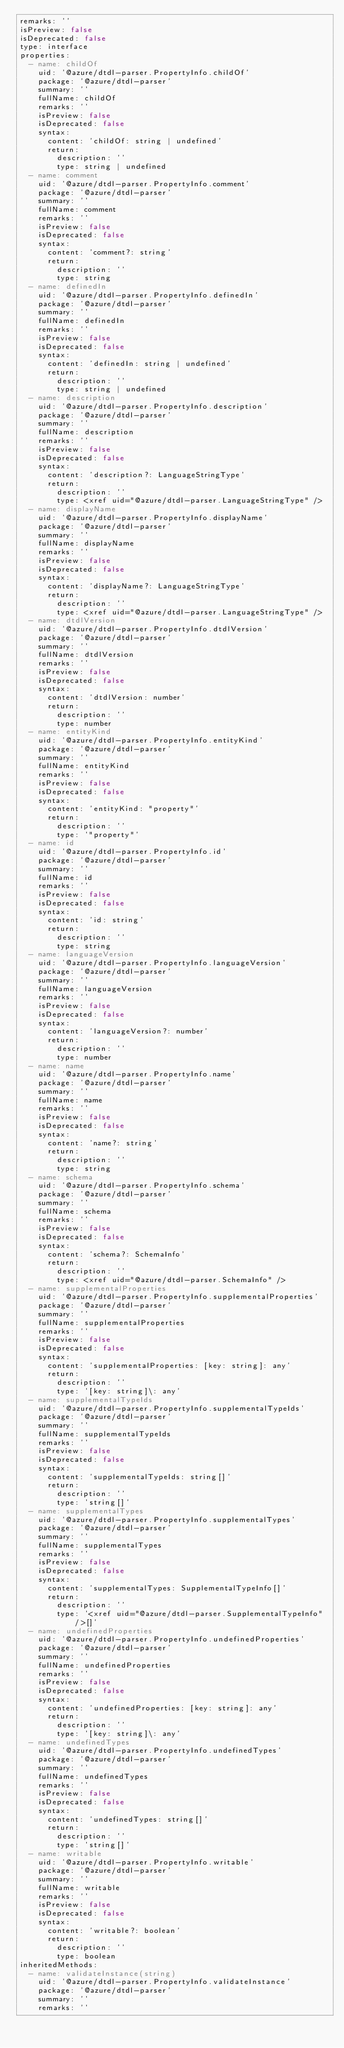Convert code to text. <code><loc_0><loc_0><loc_500><loc_500><_YAML_>remarks: ''
isPreview: false
isDeprecated: false
type: interface
properties:
  - name: childOf
    uid: '@azure/dtdl-parser.PropertyInfo.childOf'
    package: '@azure/dtdl-parser'
    summary: ''
    fullName: childOf
    remarks: ''
    isPreview: false
    isDeprecated: false
    syntax:
      content: 'childOf: string | undefined'
      return:
        description: ''
        type: string | undefined
  - name: comment
    uid: '@azure/dtdl-parser.PropertyInfo.comment'
    package: '@azure/dtdl-parser'
    summary: ''
    fullName: comment
    remarks: ''
    isPreview: false
    isDeprecated: false
    syntax:
      content: 'comment?: string'
      return:
        description: ''
        type: string
  - name: definedIn
    uid: '@azure/dtdl-parser.PropertyInfo.definedIn'
    package: '@azure/dtdl-parser'
    summary: ''
    fullName: definedIn
    remarks: ''
    isPreview: false
    isDeprecated: false
    syntax:
      content: 'definedIn: string | undefined'
      return:
        description: ''
        type: string | undefined
  - name: description
    uid: '@azure/dtdl-parser.PropertyInfo.description'
    package: '@azure/dtdl-parser'
    summary: ''
    fullName: description
    remarks: ''
    isPreview: false
    isDeprecated: false
    syntax:
      content: 'description?: LanguageStringType'
      return:
        description: ''
        type: <xref uid="@azure/dtdl-parser.LanguageStringType" />
  - name: displayName
    uid: '@azure/dtdl-parser.PropertyInfo.displayName'
    package: '@azure/dtdl-parser'
    summary: ''
    fullName: displayName
    remarks: ''
    isPreview: false
    isDeprecated: false
    syntax:
      content: 'displayName?: LanguageStringType'
      return:
        description: ''
        type: <xref uid="@azure/dtdl-parser.LanguageStringType" />
  - name: dtdlVersion
    uid: '@azure/dtdl-parser.PropertyInfo.dtdlVersion'
    package: '@azure/dtdl-parser'
    summary: ''
    fullName: dtdlVersion
    remarks: ''
    isPreview: false
    isDeprecated: false
    syntax:
      content: 'dtdlVersion: number'
      return:
        description: ''
        type: number
  - name: entityKind
    uid: '@azure/dtdl-parser.PropertyInfo.entityKind'
    package: '@azure/dtdl-parser'
    summary: ''
    fullName: entityKind
    remarks: ''
    isPreview: false
    isDeprecated: false
    syntax:
      content: 'entityKind: "property"'
      return:
        description: ''
        type: '"property"'
  - name: id
    uid: '@azure/dtdl-parser.PropertyInfo.id'
    package: '@azure/dtdl-parser'
    summary: ''
    fullName: id
    remarks: ''
    isPreview: false
    isDeprecated: false
    syntax:
      content: 'id: string'
      return:
        description: ''
        type: string
  - name: languageVersion
    uid: '@azure/dtdl-parser.PropertyInfo.languageVersion'
    package: '@azure/dtdl-parser'
    summary: ''
    fullName: languageVersion
    remarks: ''
    isPreview: false
    isDeprecated: false
    syntax:
      content: 'languageVersion?: number'
      return:
        description: ''
        type: number
  - name: name
    uid: '@azure/dtdl-parser.PropertyInfo.name'
    package: '@azure/dtdl-parser'
    summary: ''
    fullName: name
    remarks: ''
    isPreview: false
    isDeprecated: false
    syntax:
      content: 'name?: string'
      return:
        description: ''
        type: string
  - name: schema
    uid: '@azure/dtdl-parser.PropertyInfo.schema'
    package: '@azure/dtdl-parser'
    summary: ''
    fullName: schema
    remarks: ''
    isPreview: false
    isDeprecated: false
    syntax:
      content: 'schema?: SchemaInfo'
      return:
        description: ''
        type: <xref uid="@azure/dtdl-parser.SchemaInfo" />
  - name: supplementalProperties
    uid: '@azure/dtdl-parser.PropertyInfo.supplementalProperties'
    package: '@azure/dtdl-parser'
    summary: ''
    fullName: supplementalProperties
    remarks: ''
    isPreview: false
    isDeprecated: false
    syntax:
      content: 'supplementalProperties: [key: string]: any'
      return:
        description: ''
        type: '[key: string]\: any'
  - name: supplementalTypeIds
    uid: '@azure/dtdl-parser.PropertyInfo.supplementalTypeIds'
    package: '@azure/dtdl-parser'
    summary: ''
    fullName: supplementalTypeIds
    remarks: ''
    isPreview: false
    isDeprecated: false
    syntax:
      content: 'supplementalTypeIds: string[]'
      return:
        description: ''
        type: 'string[]'
  - name: supplementalTypes
    uid: '@azure/dtdl-parser.PropertyInfo.supplementalTypes'
    package: '@azure/dtdl-parser'
    summary: ''
    fullName: supplementalTypes
    remarks: ''
    isPreview: false
    isDeprecated: false
    syntax:
      content: 'supplementalTypes: SupplementalTypeInfo[]'
      return:
        description: ''
        type: '<xref uid="@azure/dtdl-parser.SupplementalTypeInfo" />[]'
  - name: undefinedProperties
    uid: '@azure/dtdl-parser.PropertyInfo.undefinedProperties'
    package: '@azure/dtdl-parser'
    summary: ''
    fullName: undefinedProperties
    remarks: ''
    isPreview: false
    isDeprecated: false
    syntax:
      content: 'undefinedProperties: [key: string]: any'
      return:
        description: ''
        type: '[key: string]\: any'
  - name: undefinedTypes
    uid: '@azure/dtdl-parser.PropertyInfo.undefinedTypes'
    package: '@azure/dtdl-parser'
    summary: ''
    fullName: undefinedTypes
    remarks: ''
    isPreview: false
    isDeprecated: false
    syntax:
      content: 'undefinedTypes: string[]'
      return:
        description: ''
        type: 'string[]'
  - name: writable
    uid: '@azure/dtdl-parser.PropertyInfo.writable'
    package: '@azure/dtdl-parser'
    summary: ''
    fullName: writable
    remarks: ''
    isPreview: false
    isDeprecated: false
    syntax:
      content: 'writable?: boolean'
      return:
        description: ''
        type: boolean
inheritedMethods:
  - name: validateInstance(string)
    uid: '@azure/dtdl-parser.PropertyInfo.validateInstance'
    package: '@azure/dtdl-parser'
    summary: ''
    remarks: ''</code> 